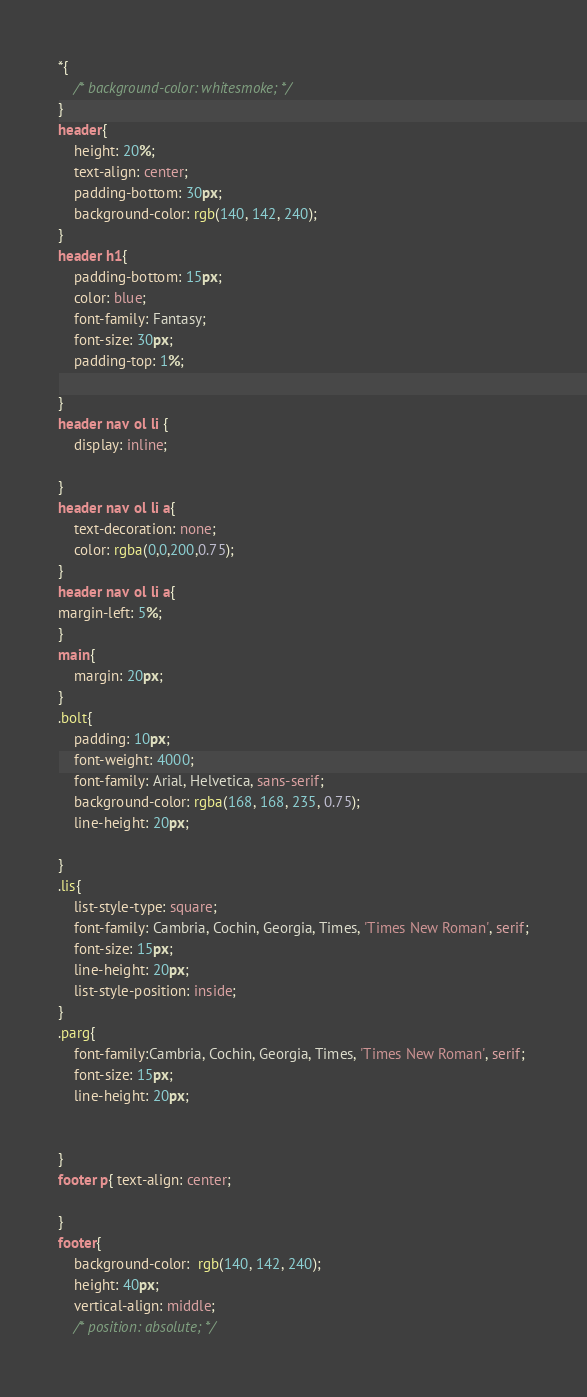Convert code to text. <code><loc_0><loc_0><loc_500><loc_500><_CSS_>*{
    /* background-color: whitesmoke; */
}
header{
    height: 20%;
    text-align: center;
    padding-bottom: 30px;
    background-color: rgb(140, 142, 240);
}
header h1{
    padding-bottom: 15px; 
    color: blue;
    font-family: Fantasy;
    font-size: 30px;
    padding-top: 1%;
    
}
header nav ol li { 
    display: inline;
    
}
header nav ol li a{
    text-decoration: none;
    color: rgba(0,0,200,0.75);
}
header nav ol li a{
margin-left: 5%;
}
main{
    margin: 20px;
}
.bolt{
    padding: 10px;
    font-weight: 4000;
    font-family: Arial, Helvetica, sans-serif;
    background-color: rgba(168, 168, 235, 0.75);
    line-height: 20px;

}
.lis{
    list-style-type: square;
    font-family: Cambria, Cochin, Georgia, Times, 'Times New Roman', serif;
    font-size: 15px;
    line-height: 20px;
    list-style-position: inside;
}
.parg{
    font-family:Cambria, Cochin, Georgia, Times, 'Times New Roman', serif;
    font-size: 15px;
    line-height: 20px;


}
footer p{ text-align: center;
    
}
footer{
    background-color:  rgb(140, 142, 240);
    height: 40px;
    vertical-align: middle;
    /* position: absolute; */
</code> 